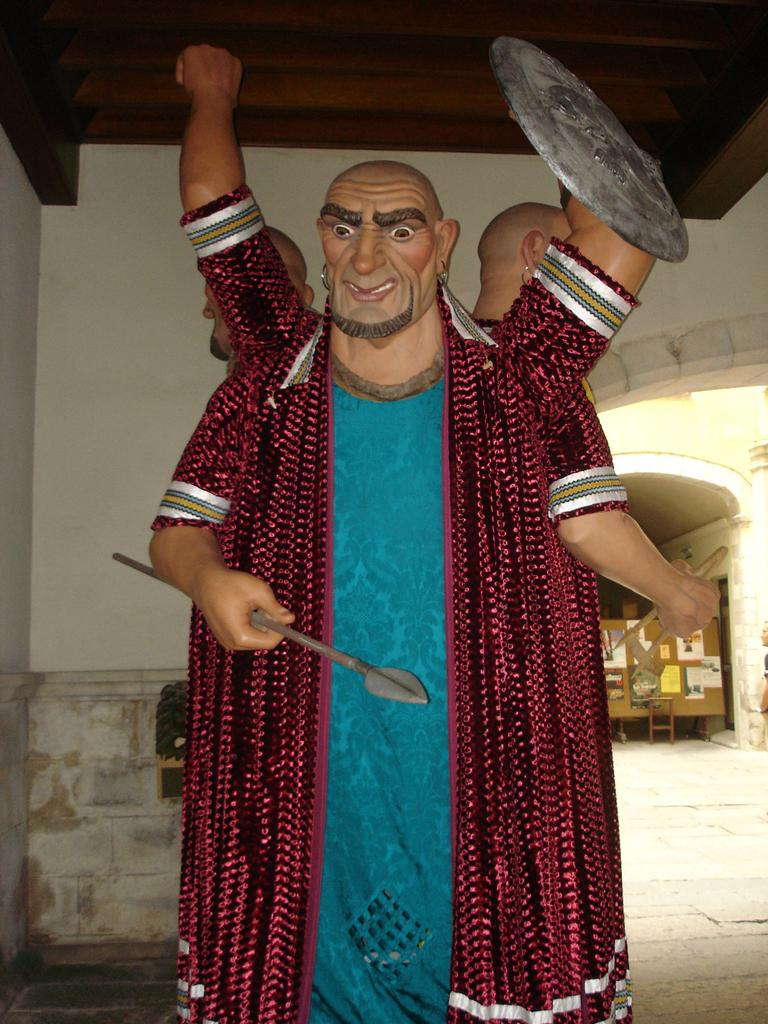What type of objects are depicted as the main subjects in the image? There are statues of persons in the image. Can you describe any additional features or objects in the background of the image? Yes, there are pipes attached to the board, floor, and walls in the background of the image. What type of metal is used to make the self in the image? There is no self present in the image; it features statues of persons. What type of cable can be seen connecting the statues in the image? There are no cables connecting the statues in the image; the statues are stationary. 